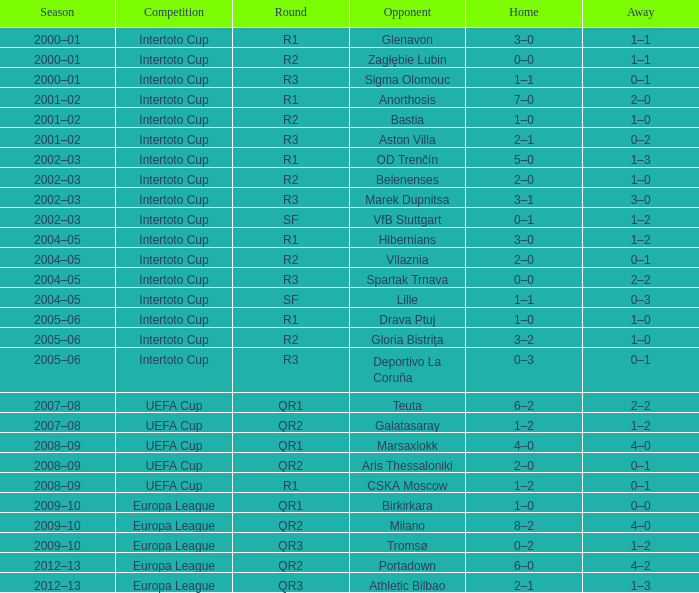What is the home score with marek dupnitsa as opponent? 3–1. 